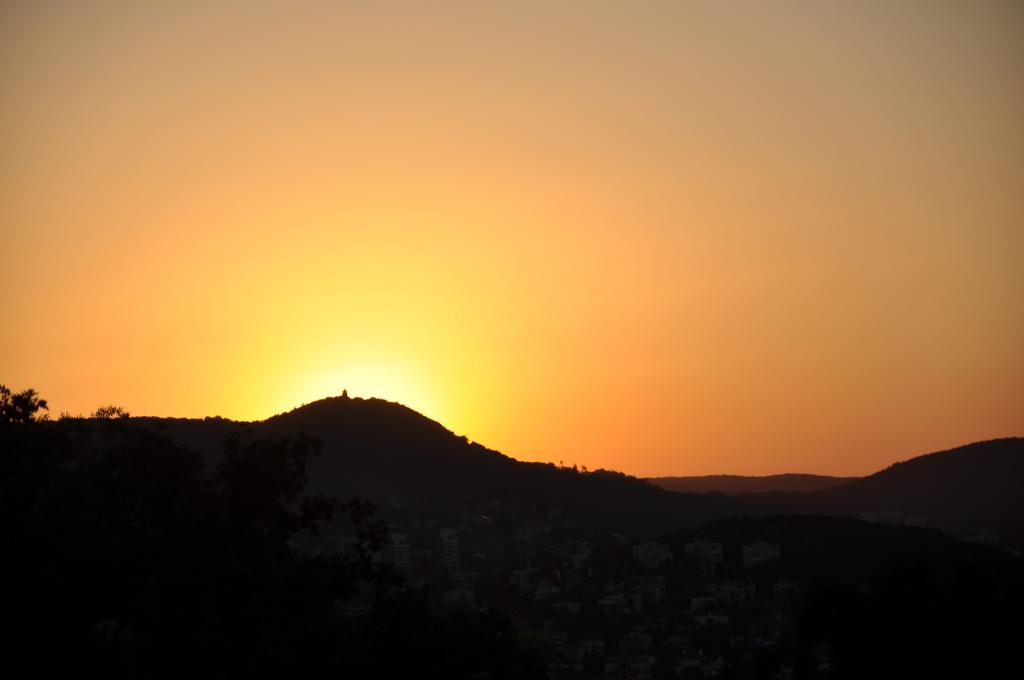What type of landscape feature can be seen in the image? There are hills in the image. What other natural elements are present in the image? There are trees in the image. Can you describe the lighting in the image? The image has a dark part, and the sun is visible. What is the color of the sky in the background? The sky has an orange color in the background. Where is the daughter standing in the image? There is no daughter present in the image; it features hills, trees, and a sky with an orange color. What type of bubble can be seen floating near the trees? There are no bubbles present in the image. 